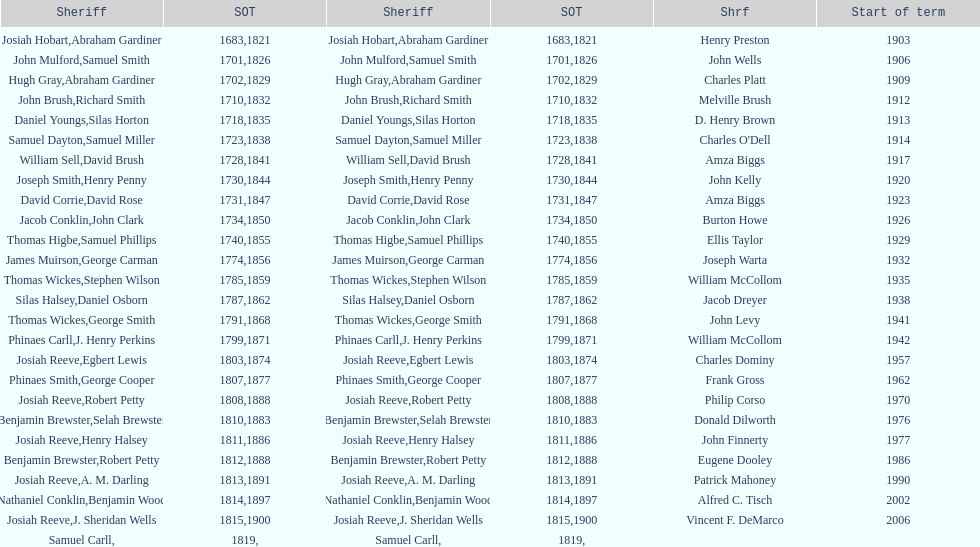When did benjamin brewster serve his second term? 1812. 